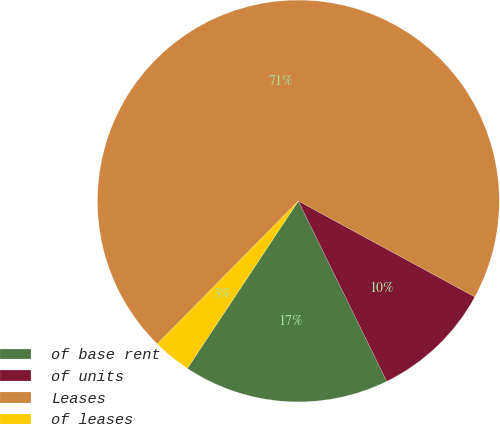Convert chart to OTSL. <chart><loc_0><loc_0><loc_500><loc_500><pie_chart><fcel>of base rent<fcel>of units<fcel>Leases<fcel>of leases<nl><fcel>16.57%<fcel>9.82%<fcel>70.53%<fcel>3.08%<nl></chart> 